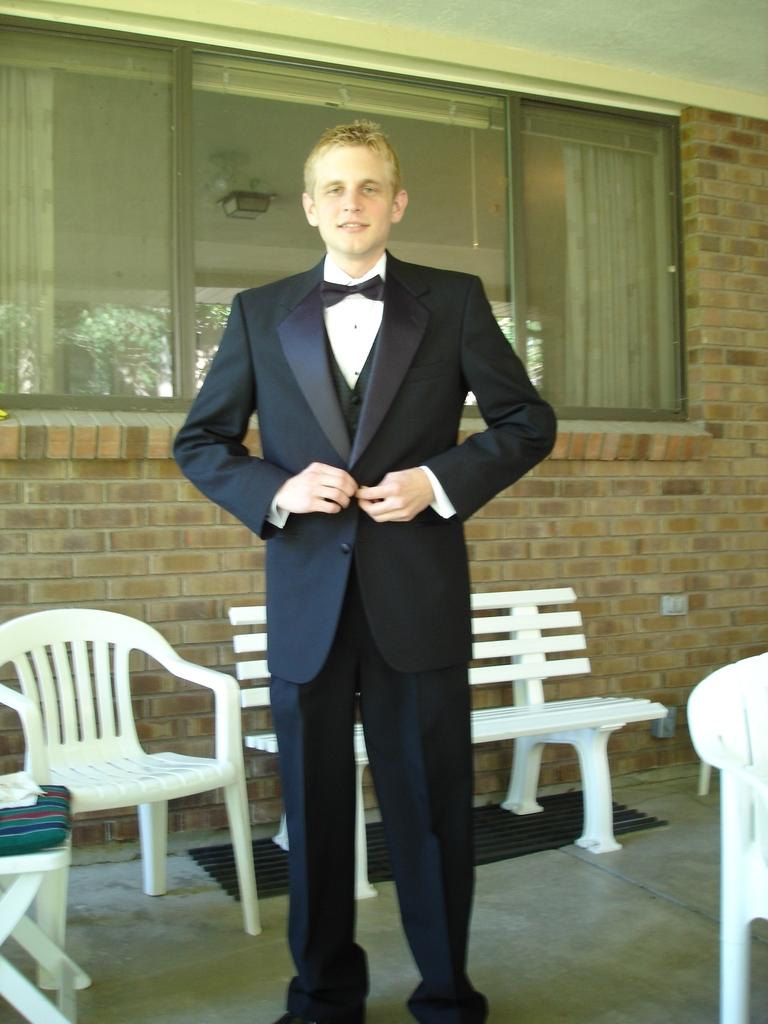Who is in the image? There is a man in the image. What is the man wearing? The man is wearing a tuxedo. What type of furniture can be seen in the image? There is a bench and a chair in the image. What architectural feature is present in the image? There is a window present in the image. What type of shoes can be seen on the flowers in the image? There are no shoes or flowers present in the image. How does the acoustics of the room affect the man's speech in the image? The provided facts do not mention anything about the acoustics of the room or the man's speech, so we cannot answer this question. 